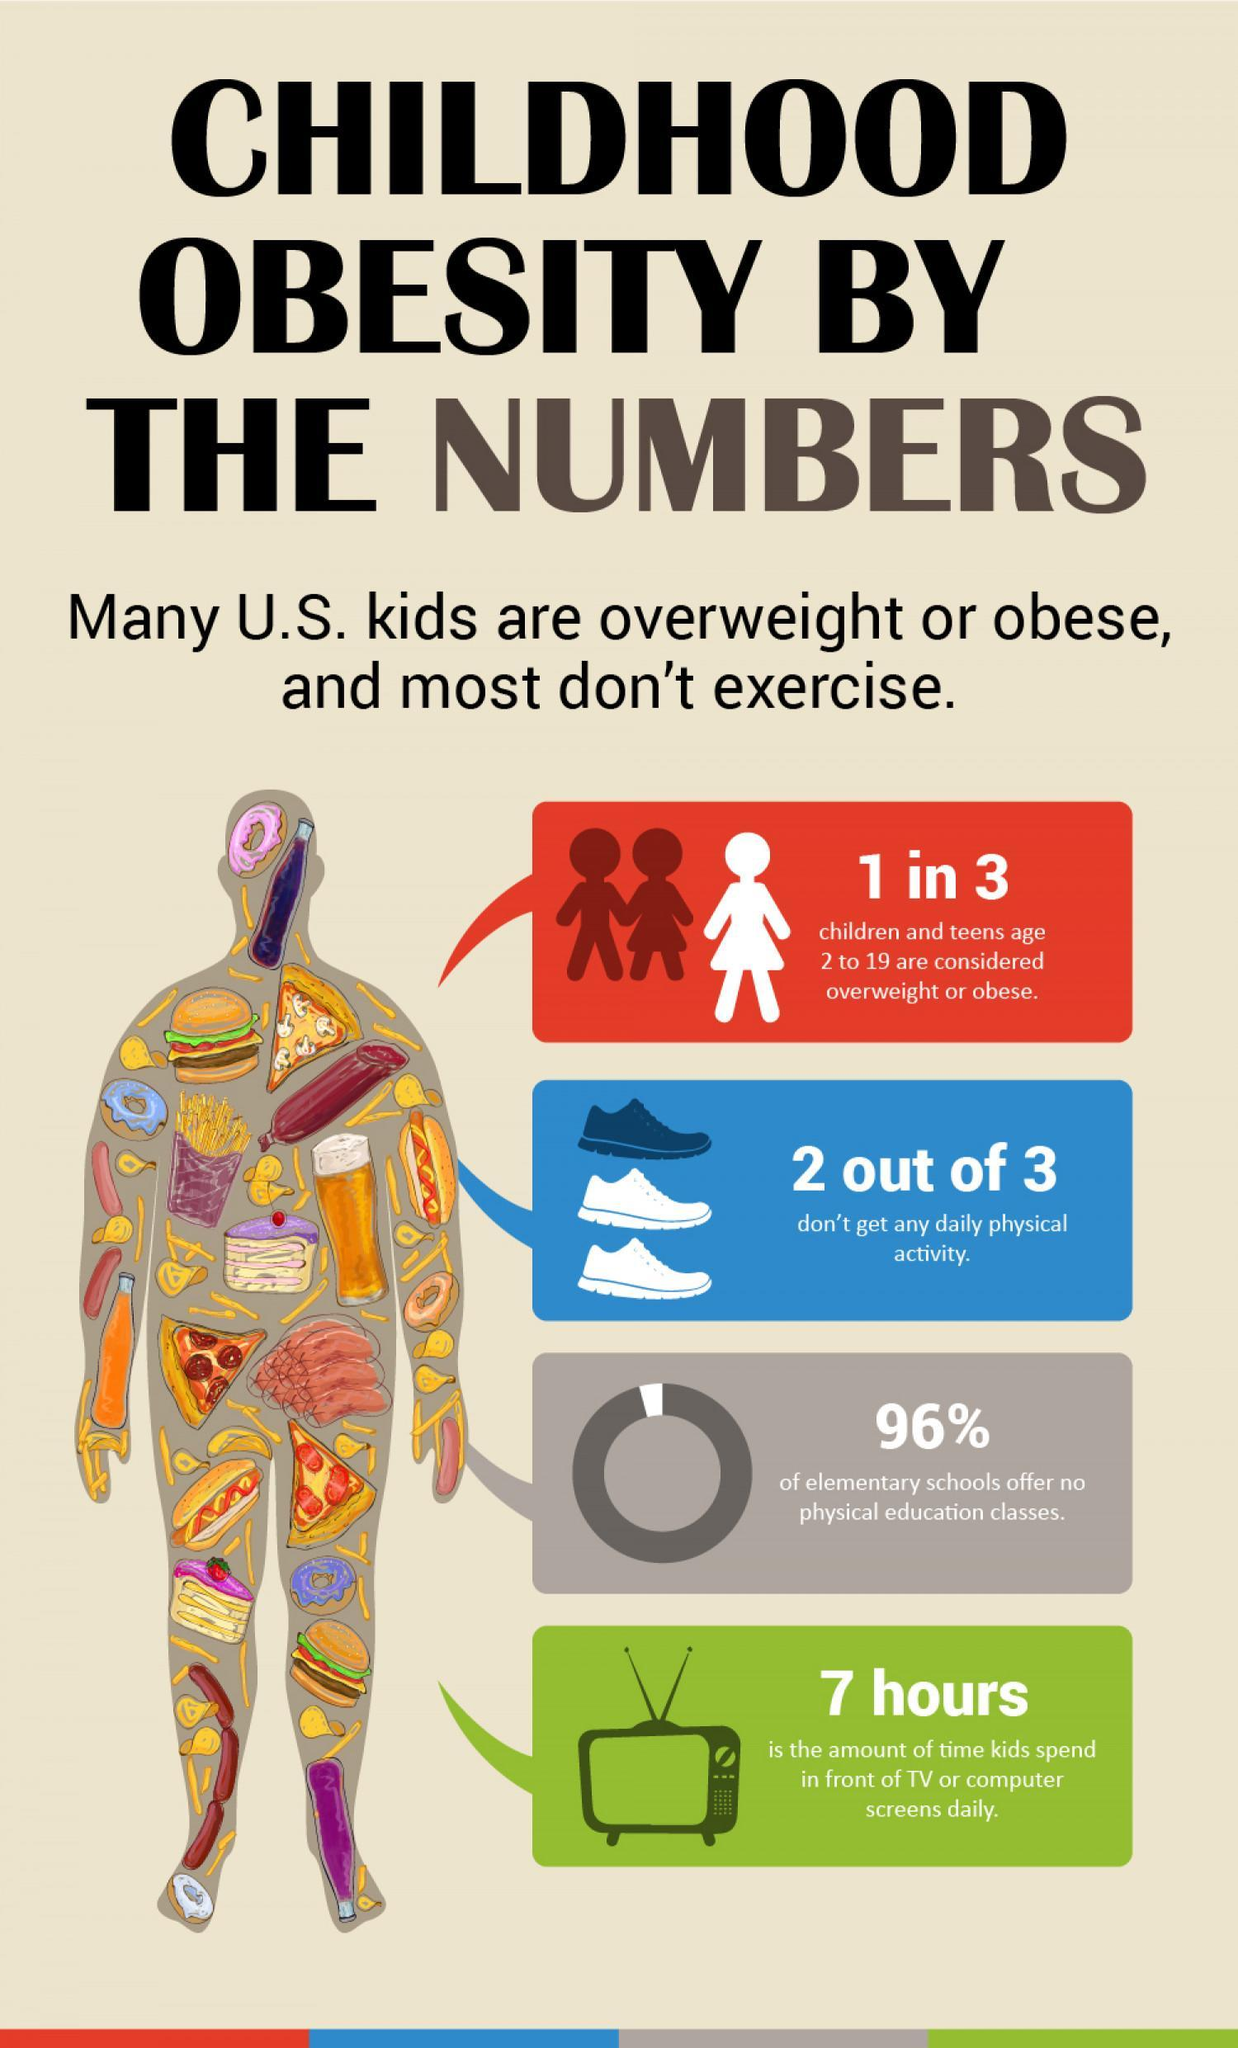In the green colored box at the bottom picture of what electonic appliance is shown - radio, washer, tv or computer?
Answer the question with a short phrase. tv What percentage of elementary schools offer physical education classes? 4% In the picture the mans figure is filled with colors , shapes or junk food? junk food 